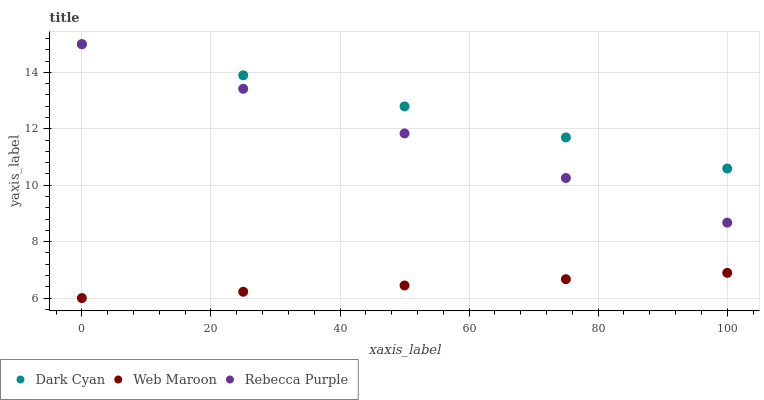Does Web Maroon have the minimum area under the curve?
Answer yes or no. Yes. Does Dark Cyan have the maximum area under the curve?
Answer yes or no. Yes. Does Rebecca Purple have the minimum area under the curve?
Answer yes or no. No. Does Rebecca Purple have the maximum area under the curve?
Answer yes or no. No. Is Web Maroon the smoothest?
Answer yes or no. Yes. Is Rebecca Purple the roughest?
Answer yes or no. Yes. Is Rebecca Purple the smoothest?
Answer yes or no. No. Is Web Maroon the roughest?
Answer yes or no. No. Does Web Maroon have the lowest value?
Answer yes or no. Yes. Does Rebecca Purple have the lowest value?
Answer yes or no. No. Does Rebecca Purple have the highest value?
Answer yes or no. Yes. Does Web Maroon have the highest value?
Answer yes or no. No. Is Web Maroon less than Dark Cyan?
Answer yes or no. Yes. Is Rebecca Purple greater than Web Maroon?
Answer yes or no. Yes. Does Dark Cyan intersect Rebecca Purple?
Answer yes or no. Yes. Is Dark Cyan less than Rebecca Purple?
Answer yes or no. No. Is Dark Cyan greater than Rebecca Purple?
Answer yes or no. No. Does Web Maroon intersect Dark Cyan?
Answer yes or no. No. 